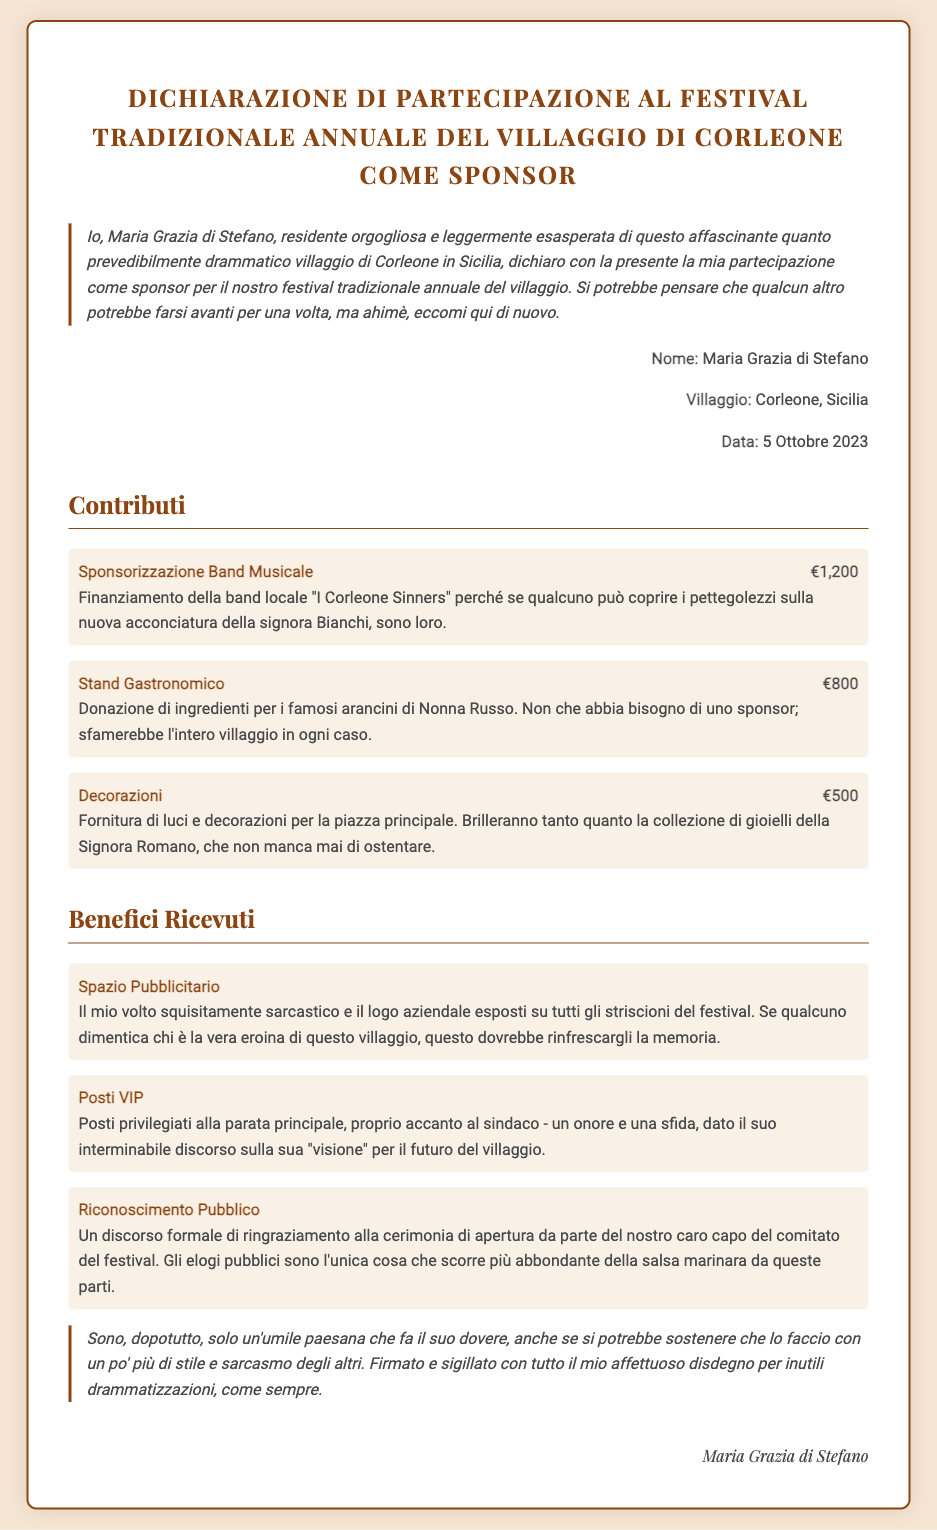what is the name of the sponsor? The document states the sponsor's name as Maria Grazia di Stefano.
Answer: Maria Grazia di Stefano what village is mentioned in the declaration? The sponsored event takes place in Corleone, as indicated in the document.
Answer: Corleone when was the declaration signed? The date of the declaration is stated as October 5, 2023.
Answer: 5 Ottobre 2023 how much was contributed for the band? The funding amount for the band "I Corleone Sinners" is specified in the document.
Answer: €1,200 what is the total contribution amount listed? The total contribution can be calculated from the individual contributions mentioned.
Answer: €2,500 what benefit involves the sponsor's image? The document describes a benefit related to advertising space featuring the sponsor's face.
Answer: Spazio Pubblicitario what is one of the benefits listed for the sponsor? The declaration outlines several benefits received, one of which is listed as VIP seating.
Answer: Posti VIP who delivers the formal speech of thanks? The document mentions the head of the festival committee as the one who gives the speech.
Answer: capo del comitato del festival what type of event is the declaration for? The declaration explicitly states it is for a traditional village festival.
Answer: festival tradizionale 